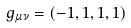Convert formula to latex. <formula><loc_0><loc_0><loc_500><loc_500>g _ { \mu \nu } = ( - 1 , 1 , 1 , 1 )</formula> 